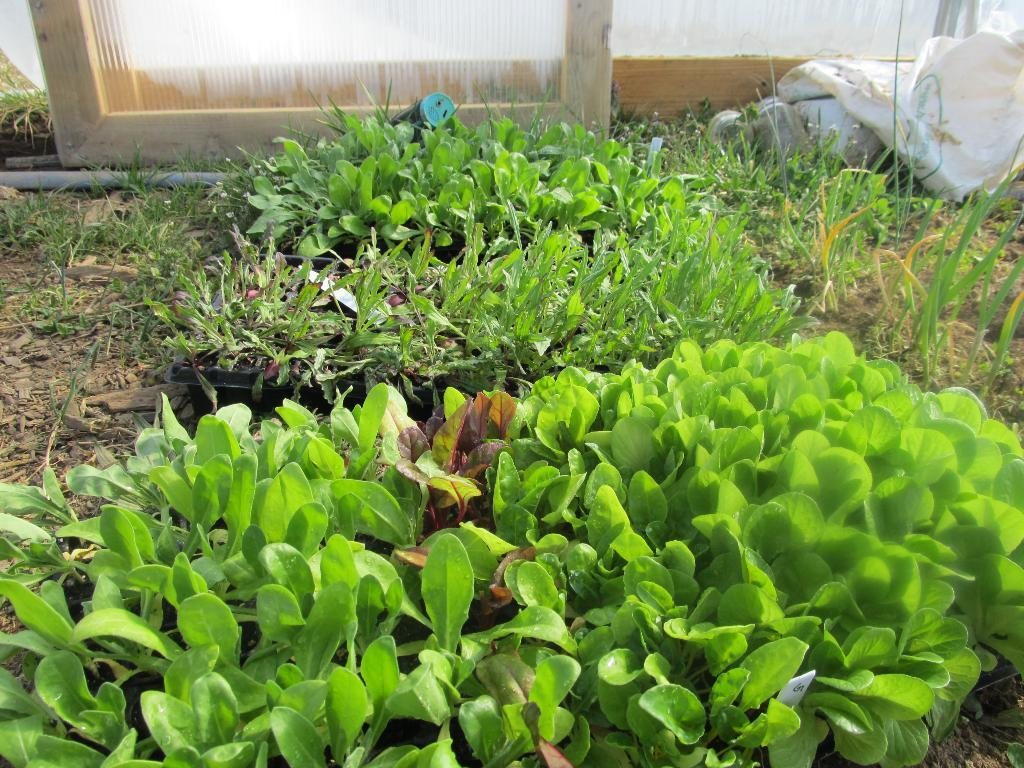What type of plants can be seen at the bottom of the image? There are flower pots and plants at the bottom of the image. What type of ground cover is present at the bottom of the image? There is grass at the bottom of the image. What type of material are the boards in the image made of? The boards in the image are made of glass. What type of material are the sticks in the image made of? The sticks in the image are made of wood. What type of objects are used to cover or protect in the image? There are covers in the image. How many cents are visible in the image? There are no cents present in the image. What type of lawyer is depicted in the image? There is no lawyer depicted in the image. 